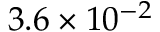<formula> <loc_0><loc_0><loc_500><loc_500>3 . 6 \times 1 0 ^ { - 2 }</formula> 